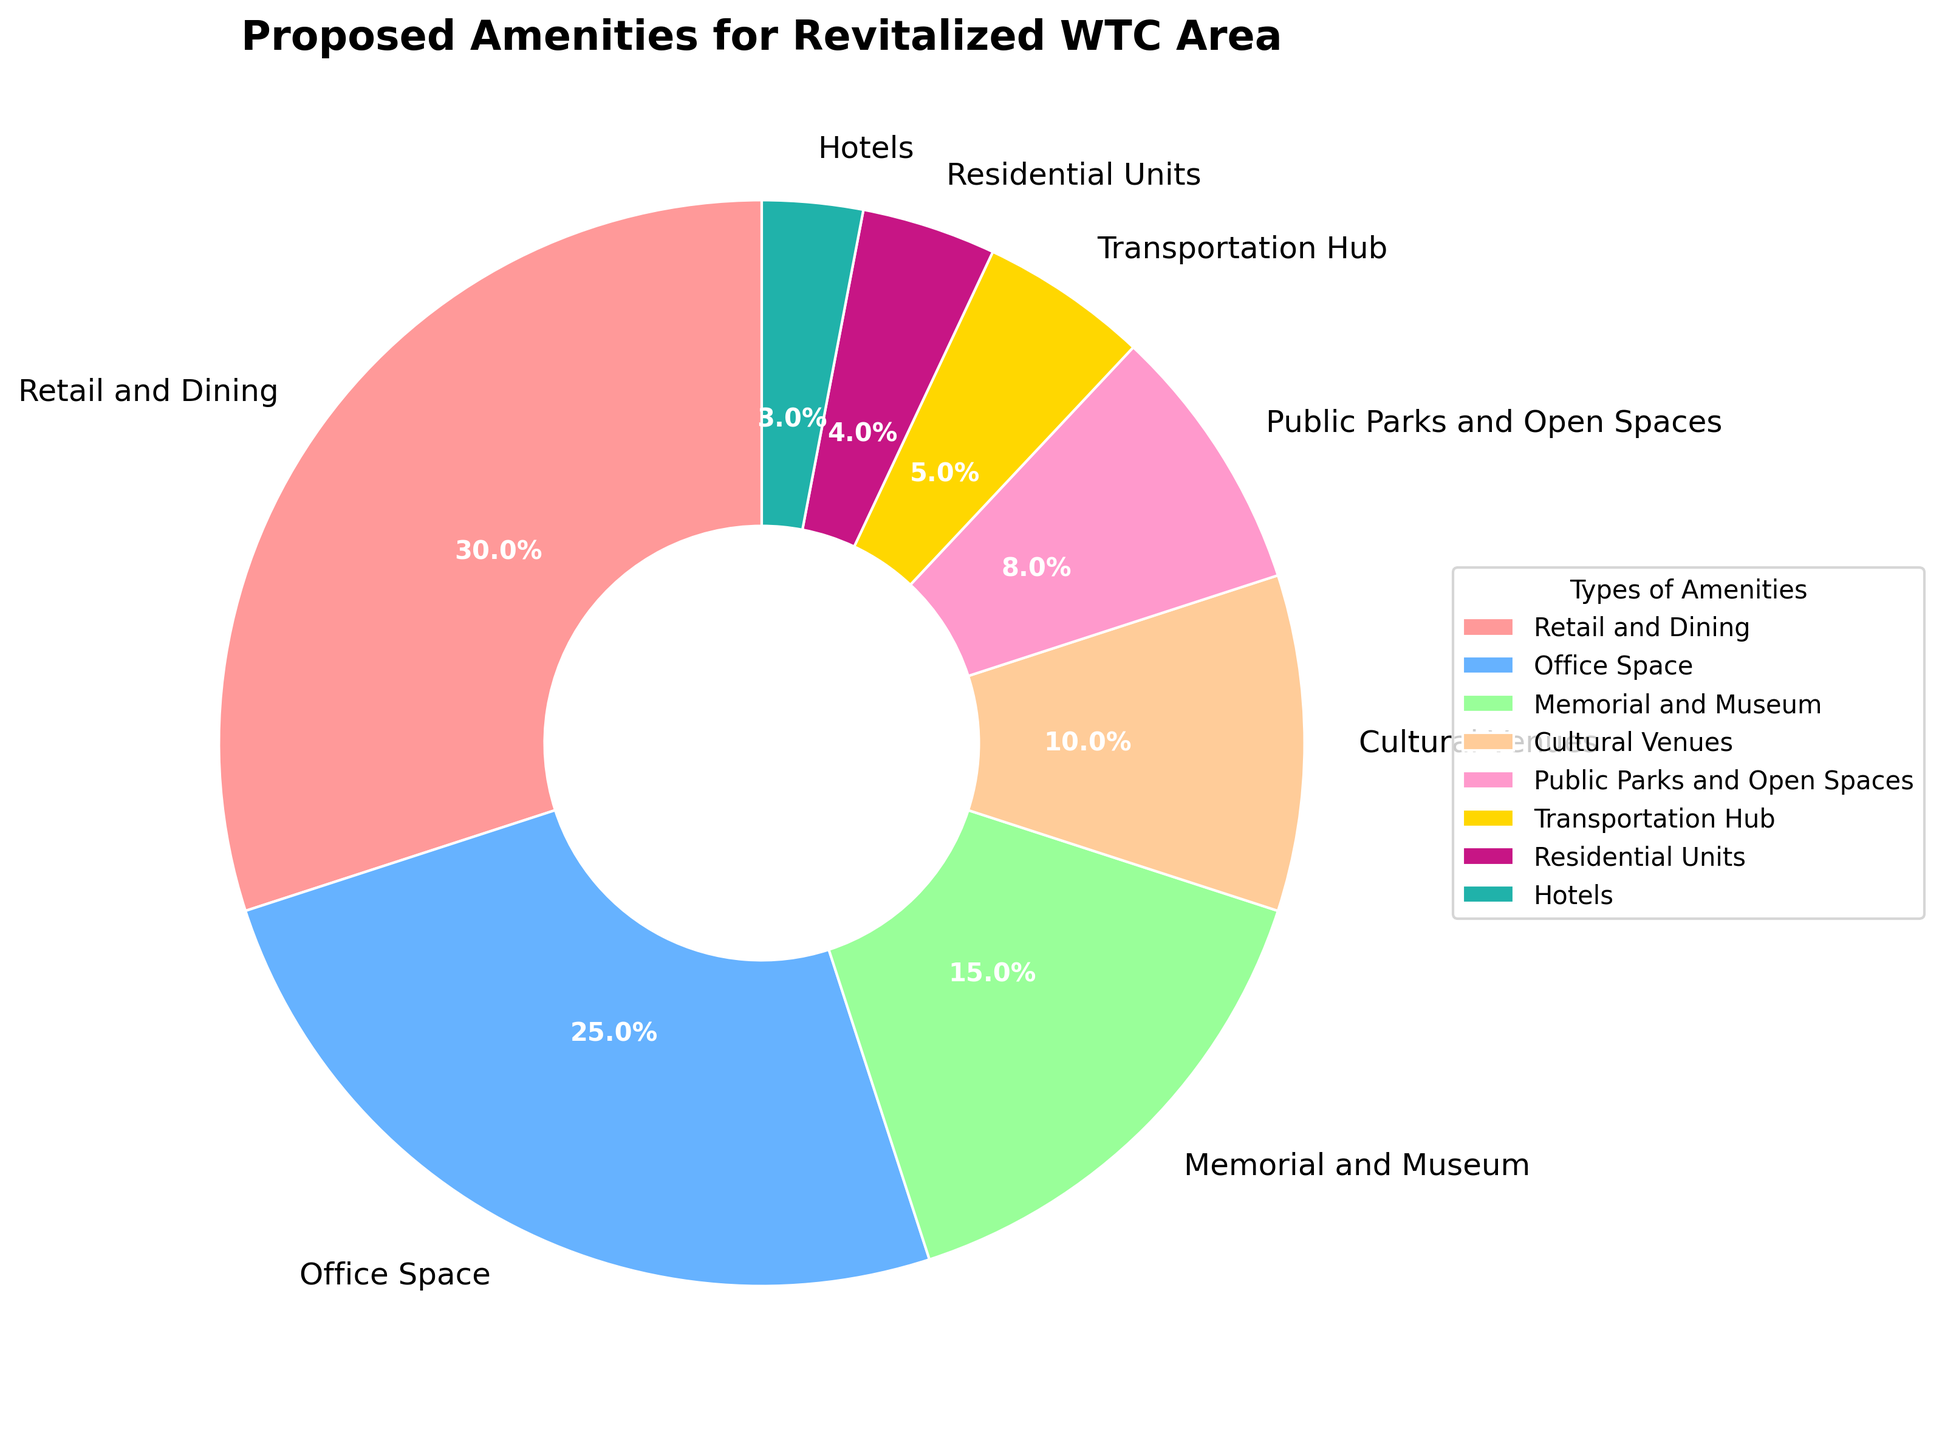What is the percentage of Retail and Dining amenities? The pie chart shows different types of amenities with their respective percentages. Locate the "Retail and Dining" section and read its percentage value.
Answer: 30% Which type of amenity has the smallest allocation? Identify the segment in the pie chart with the smallest percentage.
Answer: Hotels Is the percentage allocated for Office Space greater than that for Cultural Venues? Compare the percentages of the "Office Space" and "Cultural Venues" sections on the pie chart.
Answer: Yes What is the combined percentage of Public Parks and Open Spaces and Residential Units? Add the percentages of "Public Parks and Open Spaces" and "Residential Units" together: 8% + 4%.
Answer: 12% How much more is allocated to Retail and Dining compared to Public Parks and Open Spaces? Subtract the percentage of "Public Parks and Open Spaces" from "Retail and Dining": 30% - 8%.
Answer: 22% Which type of amenity is represented by the green color? Locate the segment of the pie chart that is colored green and read its label.
Answer: Memorial and Museum What is the difference in percentage between the highest and lowest allocated amenities? Subtract the percentage of the lowest allocated amenity (Hotels, 3%) from the highest (Retail and Dining, 30%).
Answer: 27% What percentage of the pie chart is dedicated to cultural and recreational amenities (Cultural Venues, Memorial and Museum, Public Parks and Open Spaces)? Sum the percentages of "Cultural Venues", "Memorial and Museum", and "Public Parks and Open Spaces": 10% + 15% + 8%.
Answer: 33% Are Residential Units and Hotels combined allocated more than Transportation Hub? Add the percentages of "Residential Units" and "Hotels" and compare with "Transportation Hub". 4% + 3% = 7%, which is more than 5%.
Answer: Yes What is the percentage of amenities not dedicated to Retail and Dining or Office Space? Subtract the sum of percentages for "Retail and Dining" and "Office Space" from 100%: 100% - (30% + 25%).
Answer: 45% 